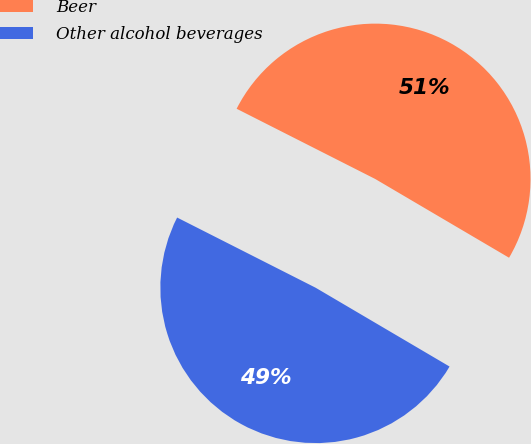Convert chart. <chart><loc_0><loc_0><loc_500><loc_500><pie_chart><fcel>Beer<fcel>Other alcohol beverages<nl><fcel>51.0%<fcel>49.0%<nl></chart> 